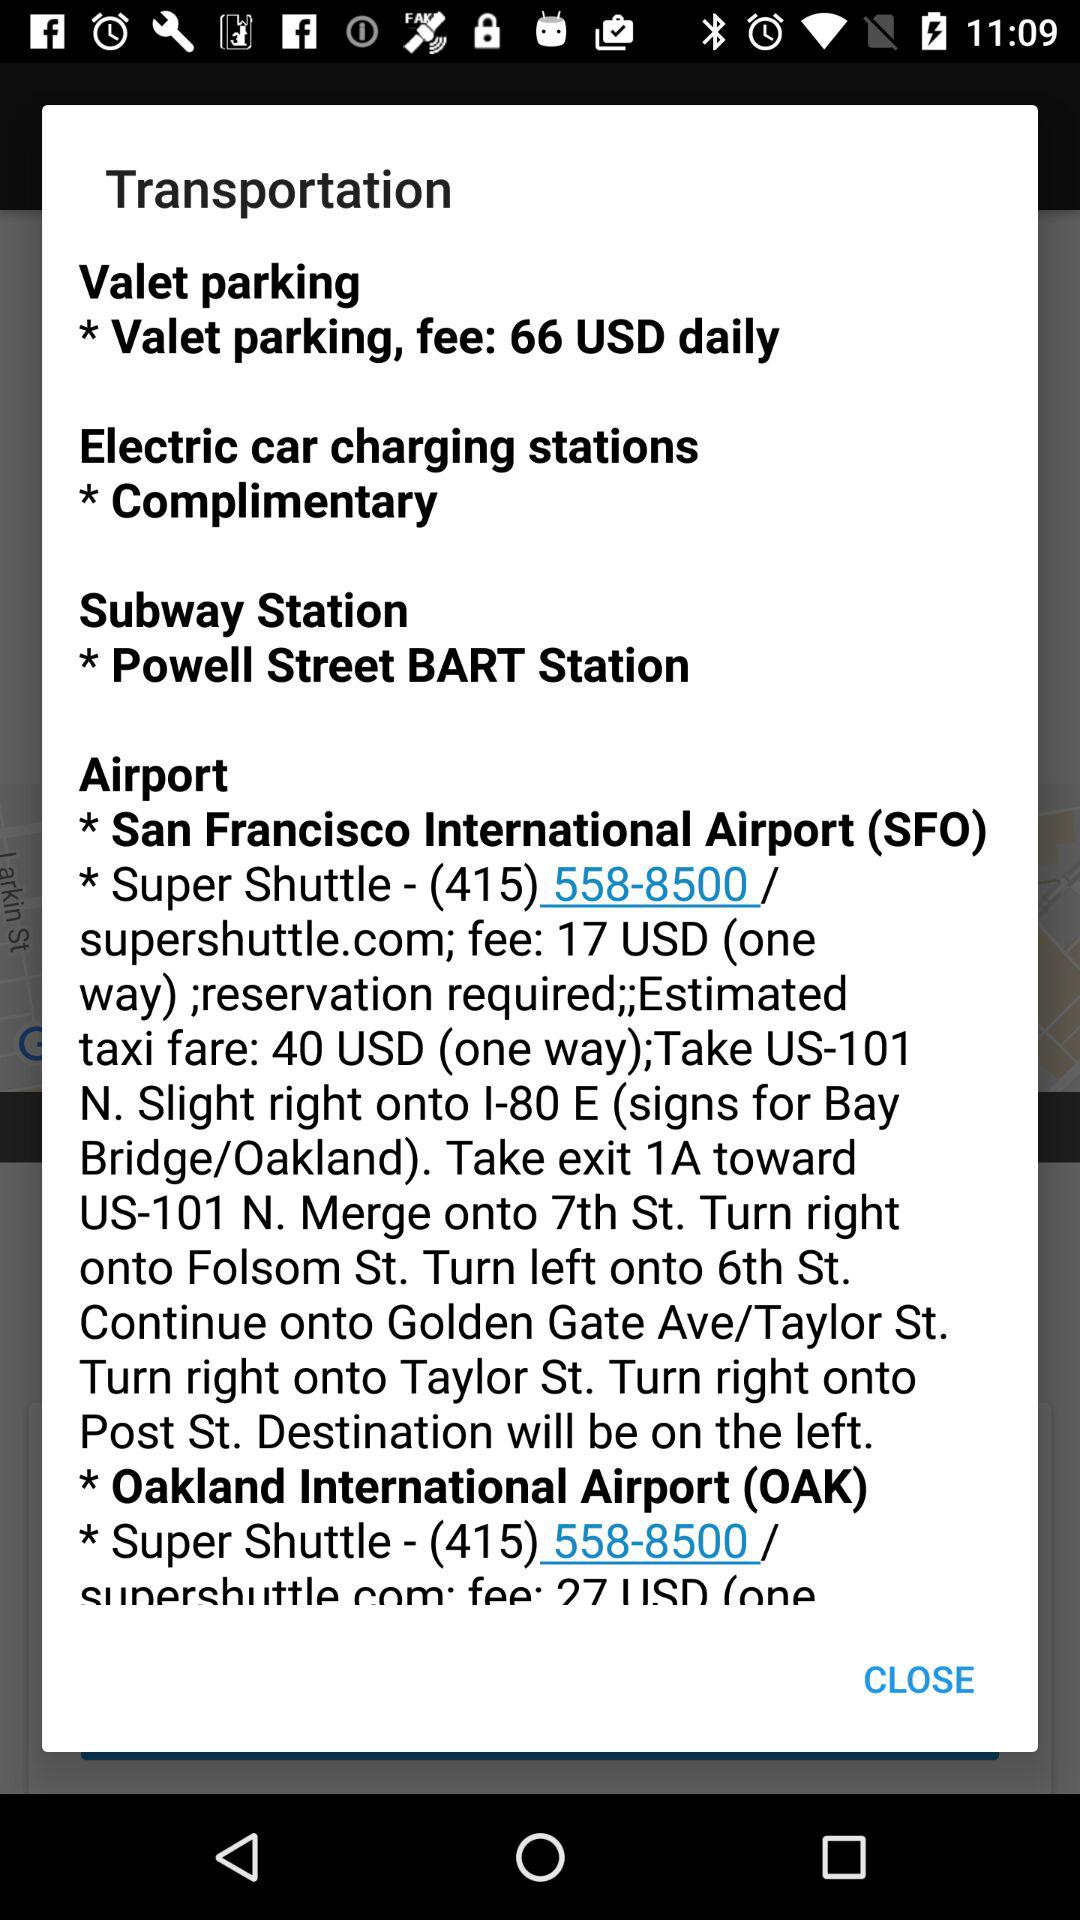What is the location of the airport? The location is "San Francisco International Airport". 